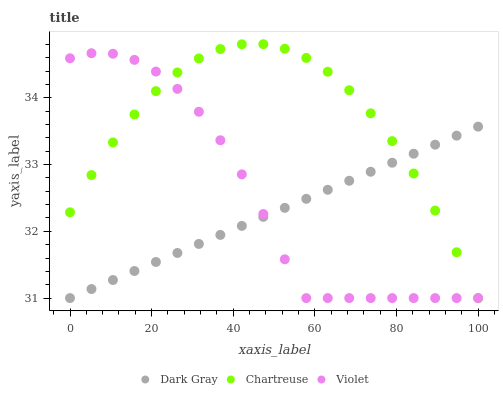Does Dark Gray have the minimum area under the curve?
Answer yes or no. Yes. Does Chartreuse have the maximum area under the curve?
Answer yes or no. Yes. Does Violet have the minimum area under the curve?
Answer yes or no. No. Does Violet have the maximum area under the curve?
Answer yes or no. No. Is Dark Gray the smoothest?
Answer yes or no. Yes. Is Violet the roughest?
Answer yes or no. Yes. Is Chartreuse the smoothest?
Answer yes or no. No. Is Chartreuse the roughest?
Answer yes or no. No. Does Dark Gray have the lowest value?
Answer yes or no. Yes. Does Chartreuse have the highest value?
Answer yes or no. Yes. Does Violet have the highest value?
Answer yes or no. No. Does Chartreuse intersect Violet?
Answer yes or no. Yes. Is Chartreuse less than Violet?
Answer yes or no. No. Is Chartreuse greater than Violet?
Answer yes or no. No. 